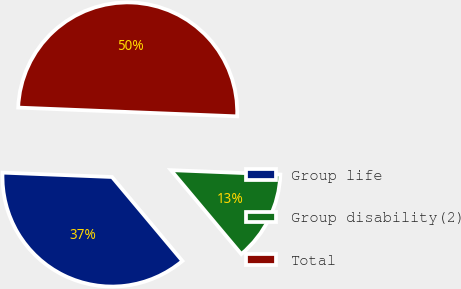Convert chart. <chart><loc_0><loc_0><loc_500><loc_500><pie_chart><fcel>Group life<fcel>Group disability(2)<fcel>Total<nl><fcel>36.74%<fcel>13.26%<fcel>50.0%<nl></chart> 